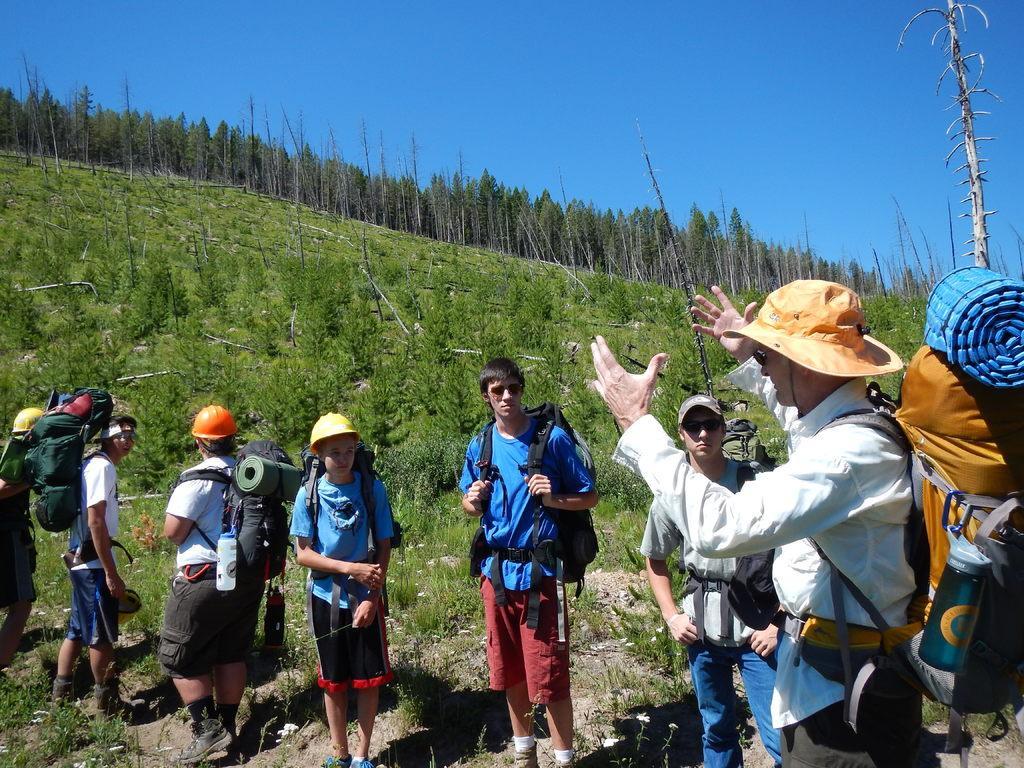How would you summarize this image in a sentence or two? In this image we can see a group of people standing on ground carrying bags, some persons are wearing helmets and some persons is wearing goggles. In the background, we can see a group of trees, hill and the sky. 